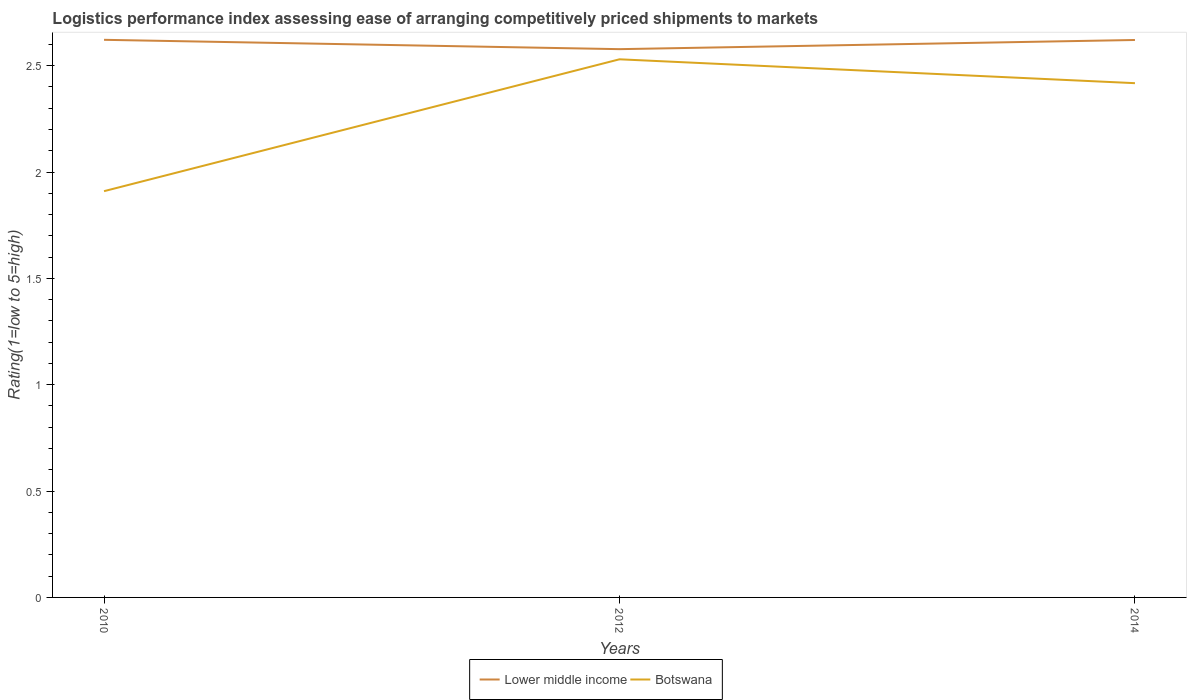How many different coloured lines are there?
Offer a terse response. 2. Does the line corresponding to Lower middle income intersect with the line corresponding to Botswana?
Keep it short and to the point. No. Across all years, what is the maximum Logistic performance index in Botswana?
Ensure brevity in your answer.  1.91. What is the total Logistic performance index in Lower middle income in the graph?
Make the answer very short. 0.04. What is the difference between the highest and the second highest Logistic performance index in Lower middle income?
Give a very brief answer. 0.04. How many years are there in the graph?
Keep it short and to the point. 3. Are the values on the major ticks of Y-axis written in scientific E-notation?
Ensure brevity in your answer.  No. How many legend labels are there?
Provide a short and direct response. 2. What is the title of the graph?
Your response must be concise. Logistics performance index assessing ease of arranging competitively priced shipments to markets. What is the label or title of the X-axis?
Make the answer very short. Years. What is the label or title of the Y-axis?
Your answer should be very brief. Rating(1=low to 5=high). What is the Rating(1=low to 5=high) in Lower middle income in 2010?
Give a very brief answer. 2.62. What is the Rating(1=low to 5=high) in Botswana in 2010?
Make the answer very short. 1.91. What is the Rating(1=low to 5=high) in Lower middle income in 2012?
Provide a succinct answer. 2.58. What is the Rating(1=low to 5=high) in Botswana in 2012?
Provide a short and direct response. 2.53. What is the Rating(1=low to 5=high) in Lower middle income in 2014?
Your answer should be compact. 2.62. What is the Rating(1=low to 5=high) in Botswana in 2014?
Offer a terse response. 2.42. Across all years, what is the maximum Rating(1=low to 5=high) of Lower middle income?
Make the answer very short. 2.62. Across all years, what is the maximum Rating(1=low to 5=high) in Botswana?
Your answer should be very brief. 2.53. Across all years, what is the minimum Rating(1=low to 5=high) of Lower middle income?
Give a very brief answer. 2.58. Across all years, what is the minimum Rating(1=low to 5=high) of Botswana?
Your response must be concise. 1.91. What is the total Rating(1=low to 5=high) of Lower middle income in the graph?
Give a very brief answer. 7.82. What is the total Rating(1=low to 5=high) in Botswana in the graph?
Ensure brevity in your answer.  6.86. What is the difference between the Rating(1=low to 5=high) of Lower middle income in 2010 and that in 2012?
Your answer should be very brief. 0.04. What is the difference between the Rating(1=low to 5=high) in Botswana in 2010 and that in 2012?
Give a very brief answer. -0.62. What is the difference between the Rating(1=low to 5=high) in Lower middle income in 2010 and that in 2014?
Keep it short and to the point. 0. What is the difference between the Rating(1=low to 5=high) in Botswana in 2010 and that in 2014?
Ensure brevity in your answer.  -0.51. What is the difference between the Rating(1=low to 5=high) of Lower middle income in 2012 and that in 2014?
Give a very brief answer. -0.04. What is the difference between the Rating(1=low to 5=high) in Botswana in 2012 and that in 2014?
Provide a succinct answer. 0.11. What is the difference between the Rating(1=low to 5=high) in Lower middle income in 2010 and the Rating(1=low to 5=high) in Botswana in 2012?
Offer a terse response. 0.09. What is the difference between the Rating(1=low to 5=high) of Lower middle income in 2010 and the Rating(1=low to 5=high) of Botswana in 2014?
Offer a very short reply. 0.2. What is the difference between the Rating(1=low to 5=high) of Lower middle income in 2012 and the Rating(1=low to 5=high) of Botswana in 2014?
Ensure brevity in your answer.  0.16. What is the average Rating(1=low to 5=high) in Lower middle income per year?
Keep it short and to the point. 2.61. What is the average Rating(1=low to 5=high) of Botswana per year?
Provide a short and direct response. 2.29. In the year 2010, what is the difference between the Rating(1=low to 5=high) in Lower middle income and Rating(1=low to 5=high) in Botswana?
Offer a terse response. 0.71. In the year 2012, what is the difference between the Rating(1=low to 5=high) of Lower middle income and Rating(1=low to 5=high) of Botswana?
Provide a succinct answer. 0.05. In the year 2014, what is the difference between the Rating(1=low to 5=high) of Lower middle income and Rating(1=low to 5=high) of Botswana?
Offer a very short reply. 0.2. What is the ratio of the Rating(1=low to 5=high) in Botswana in 2010 to that in 2012?
Your response must be concise. 0.75. What is the ratio of the Rating(1=low to 5=high) in Botswana in 2010 to that in 2014?
Provide a short and direct response. 0.79. What is the ratio of the Rating(1=low to 5=high) in Lower middle income in 2012 to that in 2014?
Ensure brevity in your answer.  0.98. What is the ratio of the Rating(1=low to 5=high) in Botswana in 2012 to that in 2014?
Your response must be concise. 1.05. What is the difference between the highest and the second highest Rating(1=low to 5=high) in Lower middle income?
Your response must be concise. 0. What is the difference between the highest and the second highest Rating(1=low to 5=high) in Botswana?
Your answer should be compact. 0.11. What is the difference between the highest and the lowest Rating(1=low to 5=high) in Lower middle income?
Give a very brief answer. 0.04. What is the difference between the highest and the lowest Rating(1=low to 5=high) in Botswana?
Keep it short and to the point. 0.62. 